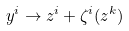<formula> <loc_0><loc_0><loc_500><loc_500>y ^ { i } \rightarrow z ^ { i } + \zeta ^ { i } ( z ^ { k } )</formula> 